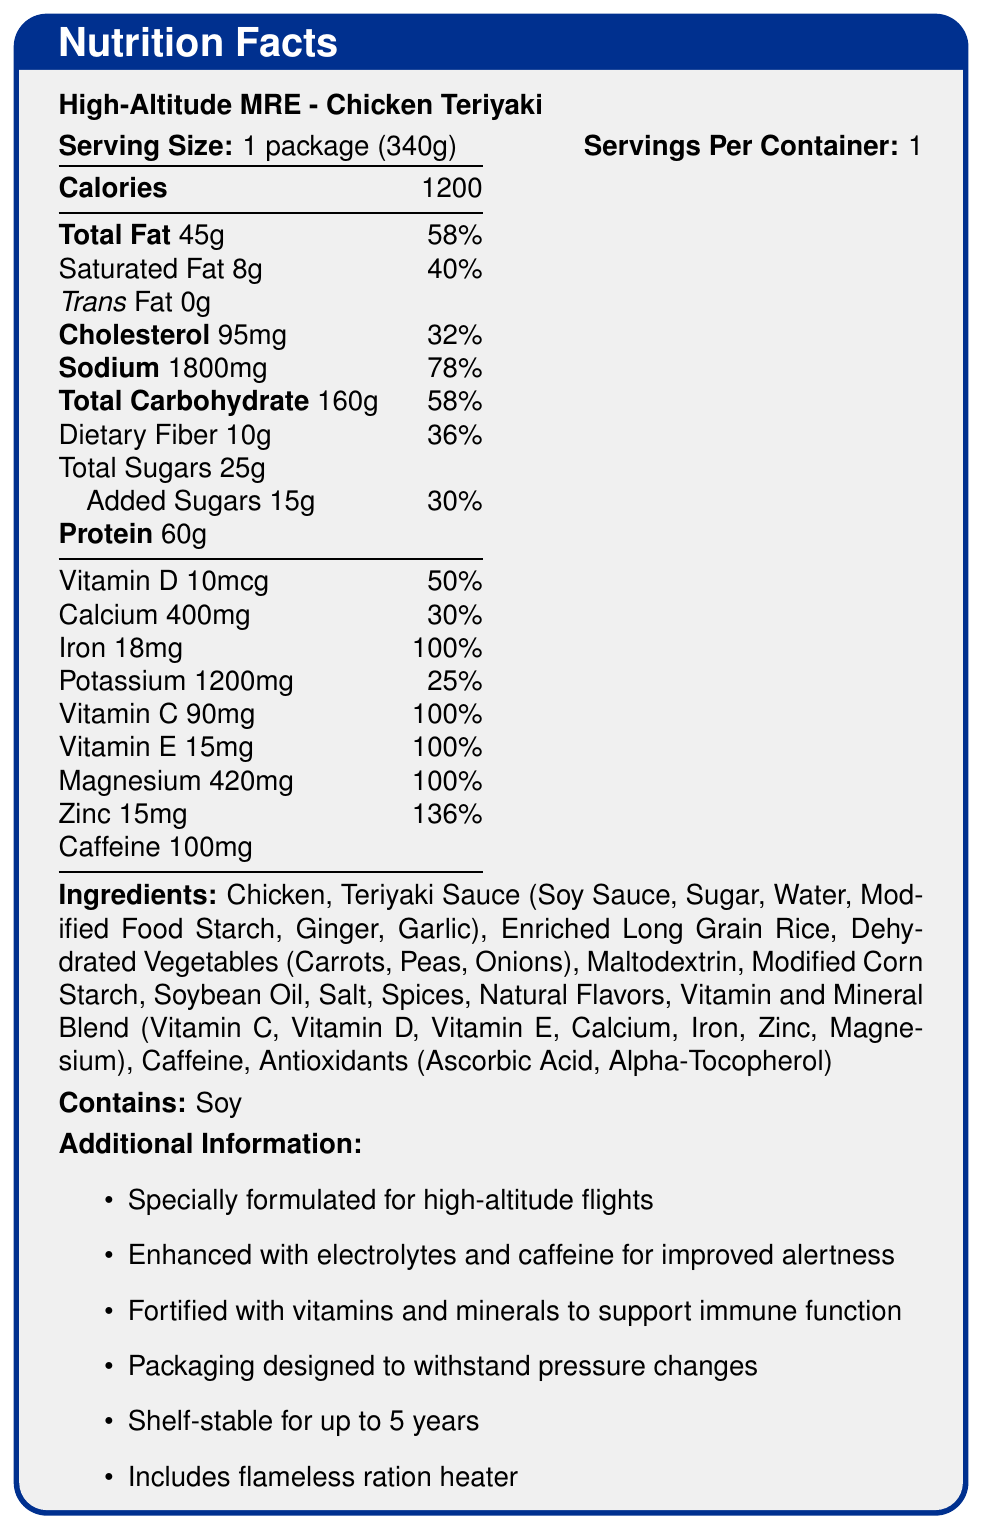what is the serving size of the High-Altitude MRE - Chicken Teriyaki? The serving size is explicitly mentioned as "1 package (340g)" in the nutrition facts.
Answer: 1 package (340g) how many calories are in one serving of this MRE? The document states that there are 1200 calories in one serving.
Answer: 1200 what percentage of the daily value of sodium does this MRE contain? The document shows that the MRE contains 1800mg of sodium, which is 78% of the daily value.
Answer: 78% Name three ingredients included in this MRE. The ingredients list mentions Chicken, Teriyaki Sauce (which includes Soy Sauce, Sugar, Water, Modified Food Starch, Ginger, Garlic), and Enriched Long Grain Rice among others.
Answer: Chicken, Teriyaki Sauce, Enriched Long Grain Rice which vitamin is NOT listed in the nutrition facts? A. Vitamin A B. Vitamin C C. Vitamin D D. Vitamin E The document lists Vitamin C, Vitamin D, and Vitamin E, but not Vitamin A.
Answer: A how much protein does this MRE provide? The nutrition facts state that this MRE contains 60g of protein.
Answer: 60g True or False: The MRE contains caffeine. The document mentions 100mg of caffeine in the nutrition facts section.
Answer: True what is the total amount of dietary fiber in this MRE? According to the document, the total dietary fiber content is 10g.
Answer: 10g what special features does the packaging of this MRE have? The document mentions that the packaging is designed to withstand pressure changes and is shelf-stable for up to 5 years.
Answer: Designed to withstand pressure changes, Shelf-stable for up to 5 years how much iron does this MRE contain? The MRE contains 18mg of iron, which is 100% of the daily value.
Answer: 18mg (100% daily value) which allergen is present in this MRE? The document indicates that this MRE contains soy as an allergen.
Answer: Soy Describe the main idea of the document. The document outlines the serving size, calories, macronutrients, vitamins, minerals, and special features of the High-Altitude MRE - Chicken Teriyaki. It highlights its suitability for high-altitude flights, its enhanced electrolytes, and vitamins for improved alertness and immune function, pressure-resistant packaging, and a long shelf-life.
Answer: The document provides detailed nutrition facts, ingredients, allergens, and additional information about a specialized military meal, the High-Altitude MRE - Chicken Teriyaki, designed for high-altitude flights. Is this MRE suitable for vegetarians? The MRE contains chicken, which is not suitable for vegetarians.
Answer: No How many grams of added sugars does this MRE have? The document states that the MRE contains 15g of added sugars.
Answer: 15g what is the potassium content in this MRE? According to the nutrition facts, the MRE contains 1200mg of potassium.
Answer: 1200mg can you determine the cost of this MRE from the document? The document does not provide any information regarding the cost of this MRE.
Answer: Cannot be determined 